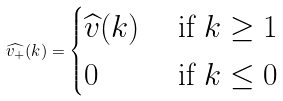Convert formula to latex. <formula><loc_0><loc_0><loc_500><loc_500>\widehat { v _ { + } } ( k ) = \begin{cases} \widehat { v } ( k ) & \text { if } k \geq 1 \\ 0 & \text { if } k \leq 0 \end{cases}</formula> 